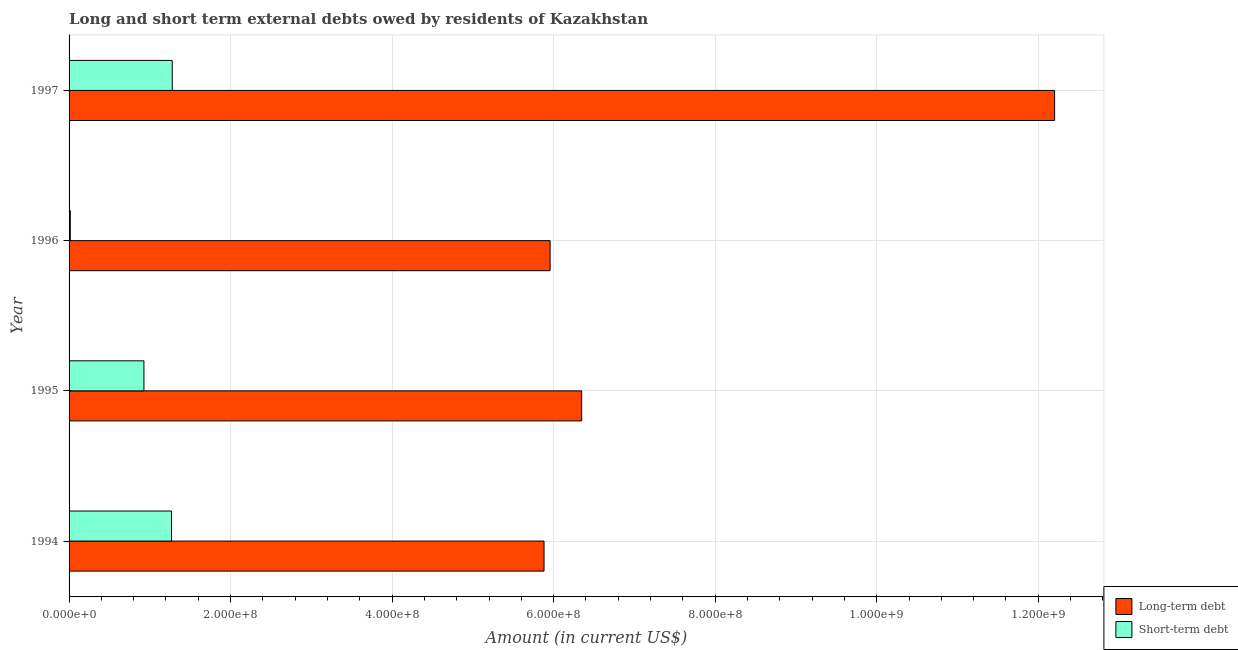How many different coloured bars are there?
Offer a very short reply. 2. Are the number of bars per tick equal to the number of legend labels?
Your response must be concise. Yes. How many bars are there on the 2nd tick from the bottom?
Keep it short and to the point. 2. What is the label of the 1st group of bars from the top?
Offer a terse response. 1997. In how many cases, is the number of bars for a given year not equal to the number of legend labels?
Your response must be concise. 0. What is the long-term debts owed by residents in 1996?
Your response must be concise. 5.96e+08. Across all years, what is the maximum short-term debts owed by residents?
Offer a terse response. 1.28e+08. Across all years, what is the minimum short-term debts owed by residents?
Your answer should be compact. 1.55e+06. In which year was the short-term debts owed by residents maximum?
Provide a short and direct response. 1997. In which year was the short-term debts owed by residents minimum?
Provide a short and direct response. 1996. What is the total long-term debts owed by residents in the graph?
Make the answer very short. 3.04e+09. What is the difference between the short-term debts owed by residents in 1995 and that in 1997?
Give a very brief answer. -3.51e+07. What is the difference between the long-term debts owed by residents in 1997 and the short-term debts owed by residents in 1995?
Provide a short and direct response. 1.13e+09. What is the average short-term debts owed by residents per year?
Make the answer very short. 8.72e+07. In the year 1996, what is the difference between the long-term debts owed by residents and short-term debts owed by residents?
Provide a short and direct response. 5.94e+08. In how many years, is the long-term debts owed by residents greater than 920000000 US$?
Provide a short and direct response. 1. What is the ratio of the long-term debts owed by residents in 1996 to that in 1997?
Keep it short and to the point. 0.49. Is the short-term debts owed by residents in 1995 less than that in 1996?
Provide a short and direct response. No. Is the difference between the long-term debts owed by residents in 1995 and 1997 greater than the difference between the short-term debts owed by residents in 1995 and 1997?
Your answer should be very brief. No. What is the difference between the highest and the second highest long-term debts owed by residents?
Give a very brief answer. 5.86e+08. What is the difference between the highest and the lowest long-term debts owed by residents?
Your response must be concise. 6.32e+08. In how many years, is the short-term debts owed by residents greater than the average short-term debts owed by residents taken over all years?
Ensure brevity in your answer.  3. What does the 1st bar from the top in 1997 represents?
Ensure brevity in your answer.  Short-term debt. What does the 1st bar from the bottom in 1995 represents?
Offer a terse response. Long-term debt. How many bars are there?
Your answer should be compact. 8. How many years are there in the graph?
Your answer should be very brief. 4. How many legend labels are there?
Offer a very short reply. 2. What is the title of the graph?
Make the answer very short. Long and short term external debts owed by residents of Kazakhstan. Does "Health Care" appear as one of the legend labels in the graph?
Give a very brief answer. No. What is the label or title of the Y-axis?
Provide a succinct answer. Year. What is the Amount (in current US$) in Long-term debt in 1994?
Give a very brief answer. 5.88e+08. What is the Amount (in current US$) in Short-term debt in 1994?
Your answer should be compact. 1.27e+08. What is the Amount (in current US$) of Long-term debt in 1995?
Ensure brevity in your answer.  6.35e+08. What is the Amount (in current US$) in Short-term debt in 1995?
Provide a short and direct response. 9.27e+07. What is the Amount (in current US$) in Long-term debt in 1996?
Your answer should be compact. 5.96e+08. What is the Amount (in current US$) of Short-term debt in 1996?
Offer a very short reply. 1.55e+06. What is the Amount (in current US$) in Long-term debt in 1997?
Ensure brevity in your answer.  1.22e+09. What is the Amount (in current US$) in Short-term debt in 1997?
Make the answer very short. 1.28e+08. Across all years, what is the maximum Amount (in current US$) in Long-term debt?
Keep it short and to the point. 1.22e+09. Across all years, what is the maximum Amount (in current US$) in Short-term debt?
Offer a very short reply. 1.28e+08. Across all years, what is the minimum Amount (in current US$) in Long-term debt?
Your answer should be very brief. 5.88e+08. Across all years, what is the minimum Amount (in current US$) of Short-term debt?
Offer a very short reply. 1.55e+06. What is the total Amount (in current US$) of Long-term debt in the graph?
Your answer should be very brief. 3.04e+09. What is the total Amount (in current US$) in Short-term debt in the graph?
Your answer should be very brief. 3.49e+08. What is the difference between the Amount (in current US$) of Long-term debt in 1994 and that in 1995?
Provide a succinct answer. -4.66e+07. What is the difference between the Amount (in current US$) of Short-term debt in 1994 and that in 1995?
Offer a terse response. 3.42e+07. What is the difference between the Amount (in current US$) in Long-term debt in 1994 and that in 1996?
Make the answer very short. -7.54e+06. What is the difference between the Amount (in current US$) of Short-term debt in 1994 and that in 1996?
Your answer should be compact. 1.25e+08. What is the difference between the Amount (in current US$) of Long-term debt in 1994 and that in 1997?
Provide a succinct answer. -6.32e+08. What is the difference between the Amount (in current US$) in Short-term debt in 1994 and that in 1997?
Offer a very short reply. -8.90e+05. What is the difference between the Amount (in current US$) of Long-term debt in 1995 and that in 1996?
Your answer should be very brief. 3.91e+07. What is the difference between the Amount (in current US$) in Short-term debt in 1995 and that in 1996?
Your answer should be very brief. 9.11e+07. What is the difference between the Amount (in current US$) in Long-term debt in 1995 and that in 1997?
Make the answer very short. -5.86e+08. What is the difference between the Amount (in current US$) in Short-term debt in 1995 and that in 1997?
Offer a terse response. -3.51e+07. What is the difference between the Amount (in current US$) of Long-term debt in 1996 and that in 1997?
Keep it short and to the point. -6.25e+08. What is the difference between the Amount (in current US$) of Short-term debt in 1996 and that in 1997?
Keep it short and to the point. -1.26e+08. What is the difference between the Amount (in current US$) in Long-term debt in 1994 and the Amount (in current US$) in Short-term debt in 1995?
Your answer should be very brief. 4.95e+08. What is the difference between the Amount (in current US$) of Long-term debt in 1994 and the Amount (in current US$) of Short-term debt in 1996?
Offer a very short reply. 5.87e+08. What is the difference between the Amount (in current US$) of Long-term debt in 1994 and the Amount (in current US$) of Short-term debt in 1997?
Your response must be concise. 4.60e+08. What is the difference between the Amount (in current US$) in Long-term debt in 1995 and the Amount (in current US$) in Short-term debt in 1996?
Make the answer very short. 6.33e+08. What is the difference between the Amount (in current US$) in Long-term debt in 1995 and the Amount (in current US$) in Short-term debt in 1997?
Make the answer very short. 5.07e+08. What is the difference between the Amount (in current US$) of Long-term debt in 1996 and the Amount (in current US$) of Short-term debt in 1997?
Your answer should be very brief. 4.68e+08. What is the average Amount (in current US$) in Long-term debt per year?
Keep it short and to the point. 7.60e+08. What is the average Amount (in current US$) in Short-term debt per year?
Provide a short and direct response. 8.72e+07. In the year 1994, what is the difference between the Amount (in current US$) of Long-term debt and Amount (in current US$) of Short-term debt?
Provide a succinct answer. 4.61e+08. In the year 1995, what is the difference between the Amount (in current US$) of Long-term debt and Amount (in current US$) of Short-term debt?
Your answer should be very brief. 5.42e+08. In the year 1996, what is the difference between the Amount (in current US$) of Long-term debt and Amount (in current US$) of Short-term debt?
Provide a short and direct response. 5.94e+08. In the year 1997, what is the difference between the Amount (in current US$) in Long-term debt and Amount (in current US$) in Short-term debt?
Ensure brevity in your answer.  1.09e+09. What is the ratio of the Amount (in current US$) in Long-term debt in 1994 to that in 1995?
Your answer should be compact. 0.93. What is the ratio of the Amount (in current US$) of Short-term debt in 1994 to that in 1995?
Offer a very short reply. 1.37. What is the ratio of the Amount (in current US$) of Long-term debt in 1994 to that in 1996?
Offer a terse response. 0.99. What is the ratio of the Amount (in current US$) of Short-term debt in 1994 to that in 1996?
Provide a succinct answer. 81.85. What is the ratio of the Amount (in current US$) in Long-term debt in 1994 to that in 1997?
Make the answer very short. 0.48. What is the ratio of the Amount (in current US$) of Long-term debt in 1995 to that in 1996?
Provide a succinct answer. 1.07. What is the ratio of the Amount (in current US$) in Short-term debt in 1995 to that in 1996?
Offer a very short reply. 59.8. What is the ratio of the Amount (in current US$) in Long-term debt in 1995 to that in 1997?
Ensure brevity in your answer.  0.52. What is the ratio of the Amount (in current US$) in Short-term debt in 1995 to that in 1997?
Your response must be concise. 0.73. What is the ratio of the Amount (in current US$) of Long-term debt in 1996 to that in 1997?
Offer a very short reply. 0.49. What is the ratio of the Amount (in current US$) in Short-term debt in 1996 to that in 1997?
Keep it short and to the point. 0.01. What is the difference between the highest and the second highest Amount (in current US$) of Long-term debt?
Ensure brevity in your answer.  5.86e+08. What is the difference between the highest and the second highest Amount (in current US$) of Short-term debt?
Offer a very short reply. 8.90e+05. What is the difference between the highest and the lowest Amount (in current US$) of Long-term debt?
Give a very brief answer. 6.32e+08. What is the difference between the highest and the lowest Amount (in current US$) in Short-term debt?
Offer a very short reply. 1.26e+08. 